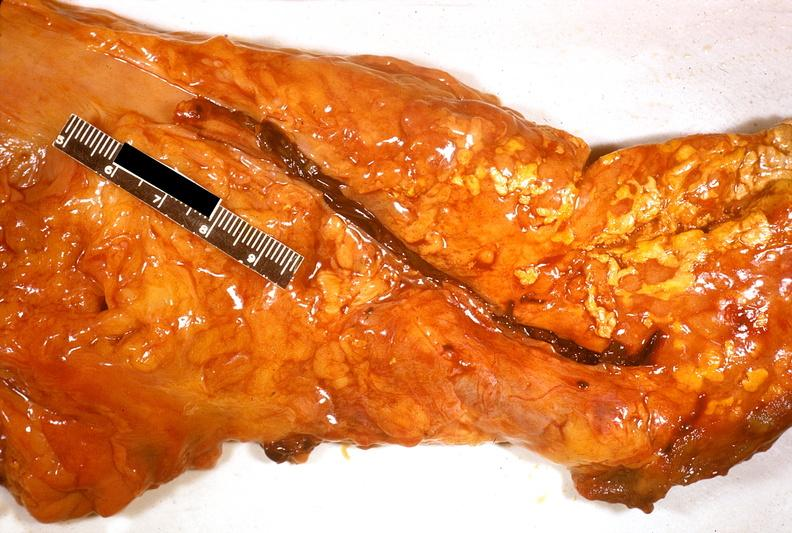does this image show acute pancreatitis?
Answer the question using a single word or phrase. Yes 